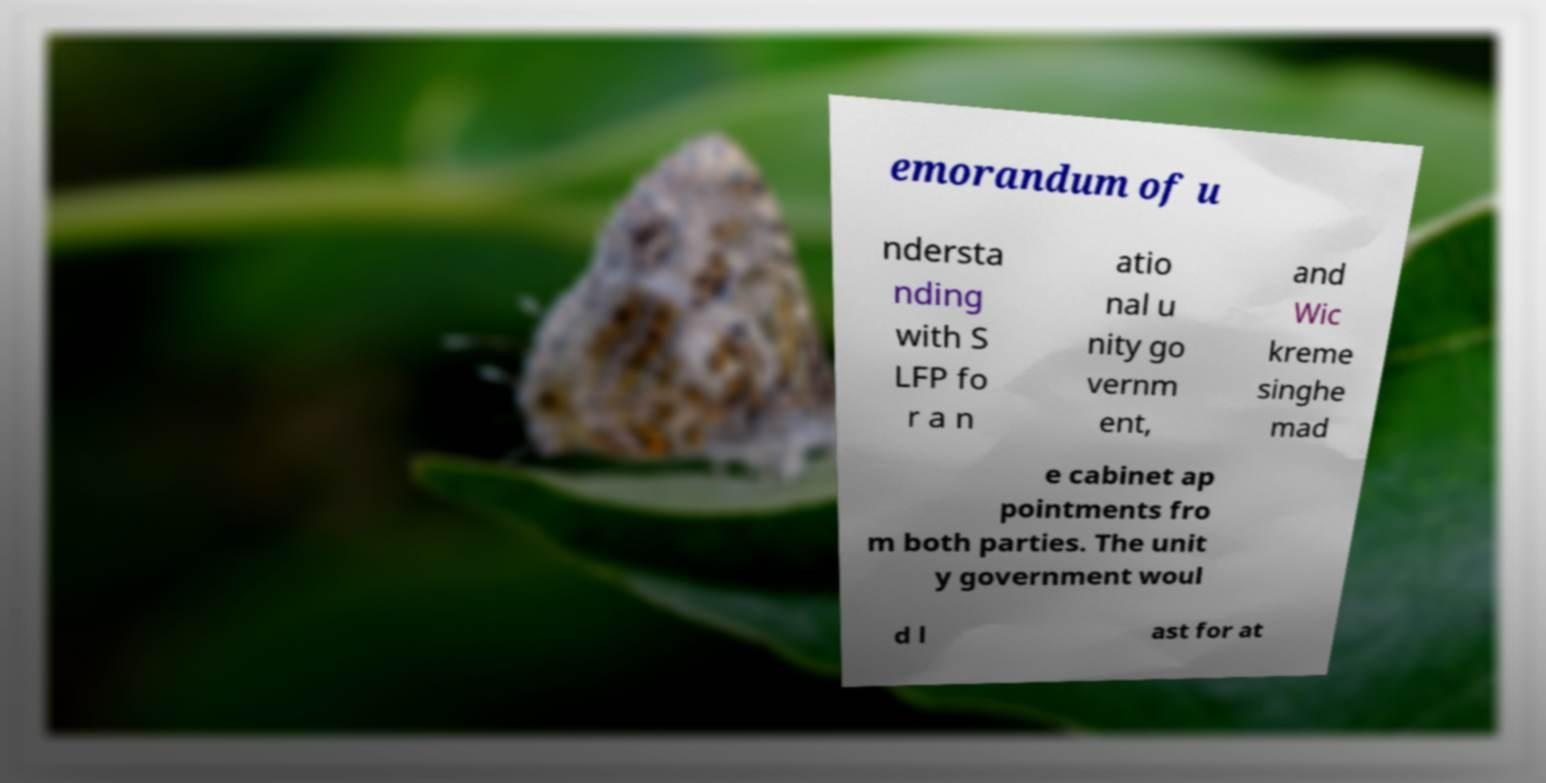What messages or text are displayed in this image? I need them in a readable, typed format. emorandum of u ndersta nding with S LFP fo r a n atio nal u nity go vernm ent, and Wic kreme singhe mad e cabinet ap pointments fro m both parties. The unit y government woul d l ast for at 